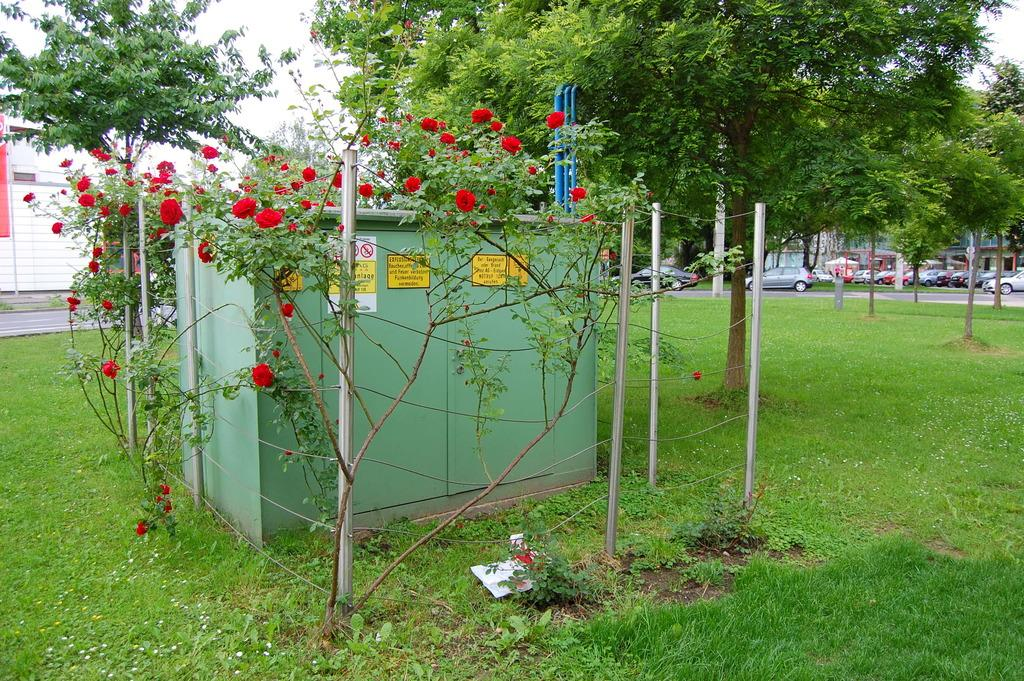What is the main object in the center of the image? There is a box in the center of the image. What type of vegetation can be seen in the image? There are plants and a tree in the image. What type of ground is visible in the image? There is grass in the bottom of the image. What else can be seen in the image besides the box and vegetation? There are many vehicles in the image. What type of pet can be seen playing with the plants in the image? There is no pet present in the image; it only features a box, plants, a tree, grass, and vehicles. 